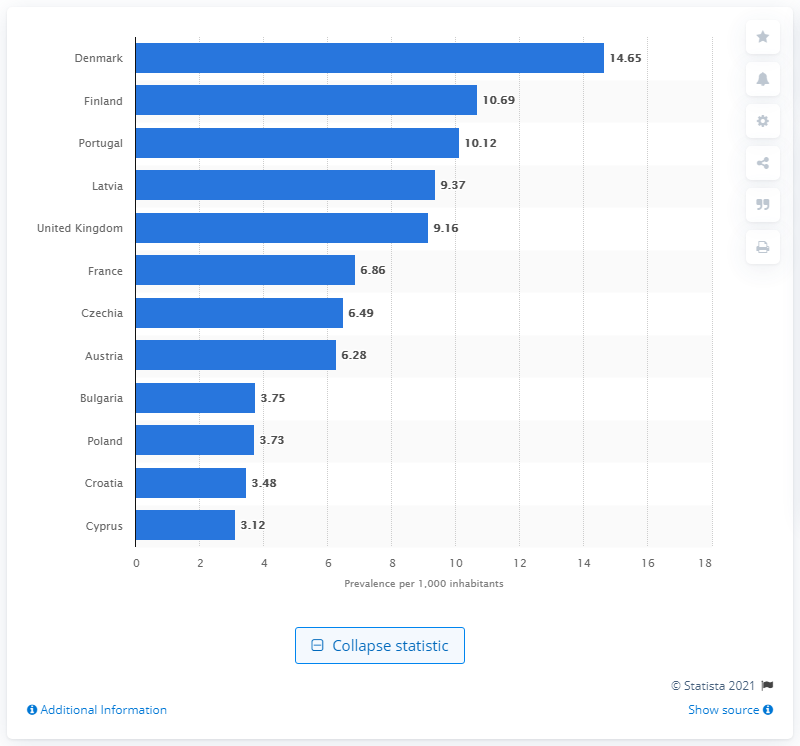Identify some key points in this picture. In 2018, there were approximately 14.65 problem drug users in Denmark. 